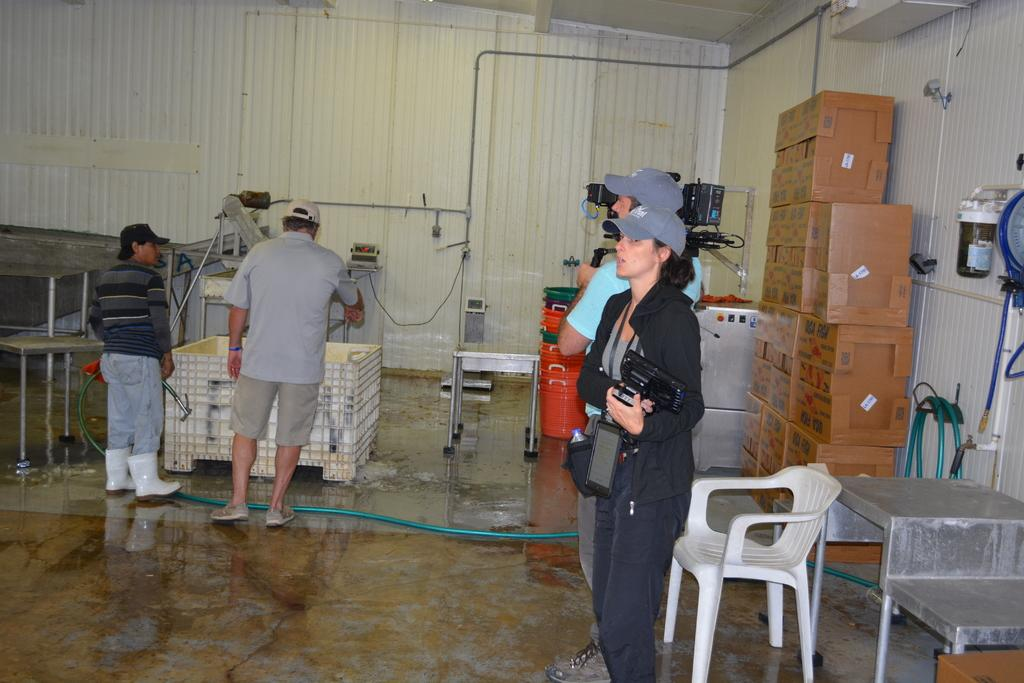How many people are in the room in the image? There are four people in the room. What are two of the people wearing? Two of the people are wearing caps. What are the two people wearing caps doing? The two people wearing caps are holding cameras. What can be seen in the background of the image? There are boxes, a system, and a bucket in the background. What type of impulse can be seen affecting the heart of the person in the image? There is no indication of an impulse or a person's heart in the image. What type of pot is being used to cook food in the image? There is no pot or cooking activity present in the image. 